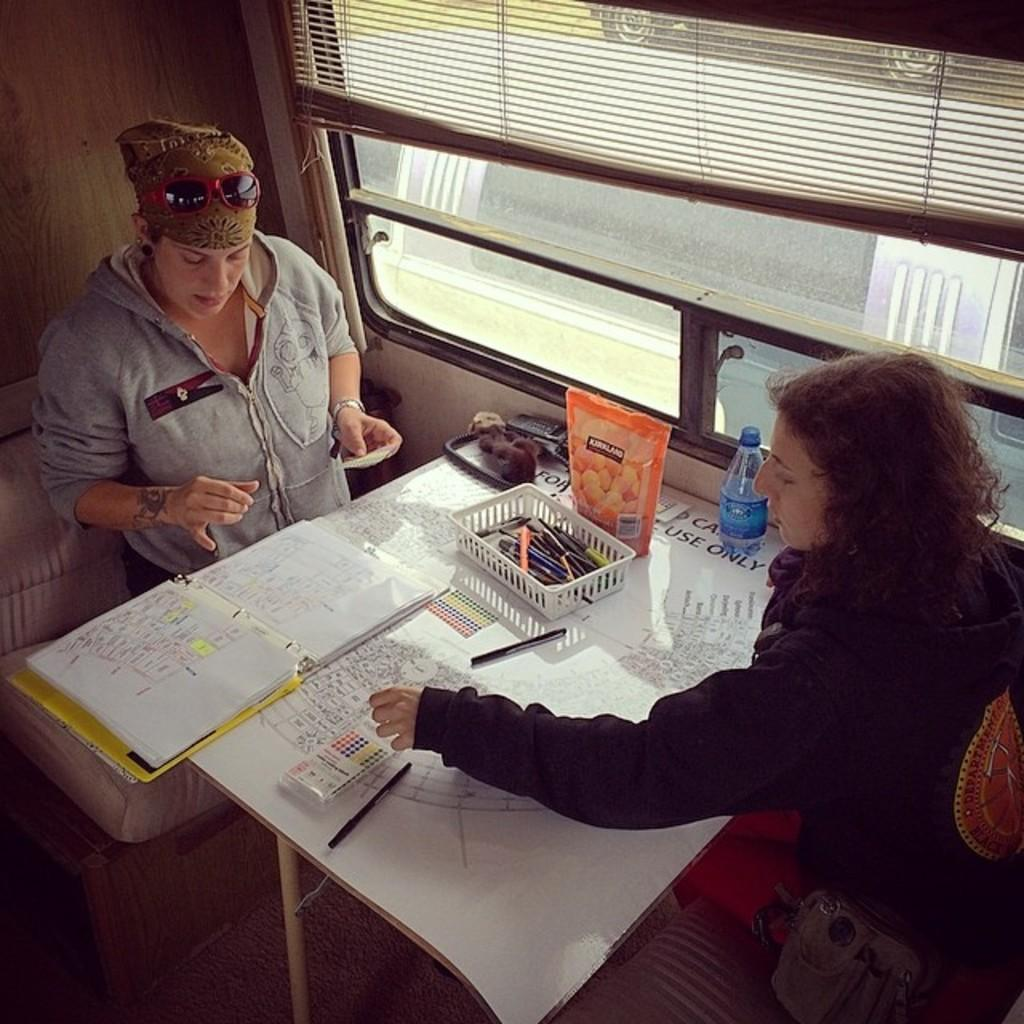How many women are in the image? There are two women in the image. What are the women doing in the image? The women are sitting on chairs. What is on the table in the image? There is a book, pens, a bottle, and a packet on the table. What type of ring can be seen on the women's fingers in the image? There are no rings visible on the women's fingers in the image. Can you hear the women talking in the image? The image is silent, so we cannot hear the women talking. 